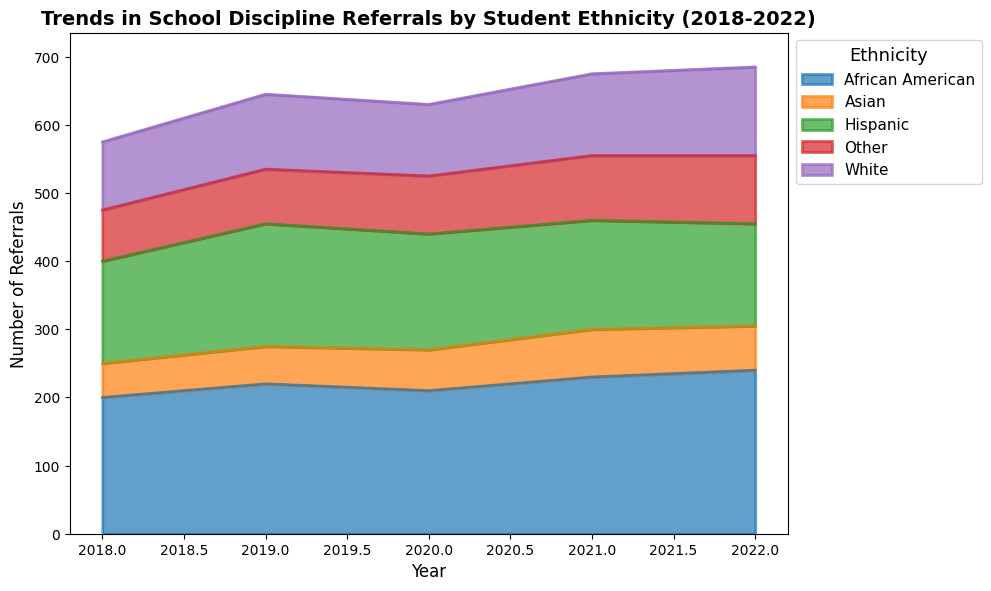What's the trend in discipline referrals for African American students over the 5 years? Analyze the chart to observe the line representing African American students. The number of referrals increased slightly overall from 200 in 2018 to 240 in 2022.
Answer: Increased Which ethnic group had the highest number of discipline referrals in 2022? Observe the heights of the areas in the chart for the year 2022. The African American group has the highest area thickness, indicating the highest number of referrals (240).
Answer: African American Compare the number of referrals for Hispanic and Asian students in 2020. Which group had more? Observe the chart and locate the data points for Hispanic and Asian students in 2020. Hispanic students had 170 referrals, and Asian students had 60 referrals.
Answer: Hispanic students Which ethnic group experienced the biggest increase in discipline referrals from 2019 to 2022? Calculate the difference in the number of referrals between 2019 and 2022 for each ethnic group. For African American (240-220 = 20), Hispanic (150-180 = -30), White (130-110 = 20), Asian (65-55 = 10), and Other (100-80 = 20). The African American, White, and Other groups all increased by 20 referrals.
Answer: African American, White, and Other (all increased by 20) What's the total number of discipline referrals recorded in 2018 across all ethnic groups? Sum the referrals for all ethnic groups in 2018. (200 + 150 + 100 + 50 + 75 = 575).
Answer: 575 Which ethnic group showed the most variability in discipline referrals over the 5 years? Observe the fluctuations in the height of the areas across the years. African American and Other groups show noticeable variability, whereas other groups have more subtle changes.
Answer: African American What was the average annual number of referrals for White students from 2018 to 2022? Sum the number of referrals for White students across the 5 years and divide by the number of years. (100 + 110 + 105 + 120 + 130) / 5 = 565 / 5 = 113.
Answer: 113 Compare the areas representing Hispanic and White students in 2020. Which group had more referrals and by how much? Observe the heights of the areas for the year 2020. Hispanic students had 170 referrals, and White students had 105 referrals. The difference is 170 - 105 = 65.
Answer: Hispanic students by 65 What's the combined total of discipline referrals for Asian and Other students in 2021? Sum the number of referrals for Asian and Other students in 2021. (70 + 95 = 165)
Answer: 165 What percentage of the total referrals in 2022 were from the White student group? First, sum all the referrals for 2022. (240 + 150 + 130 + 65 + 100 = 685). Then, calculate the percentage that came from the White student group. (130 / 685) * 100 = ~18.98%.
Answer: ~18.98% 